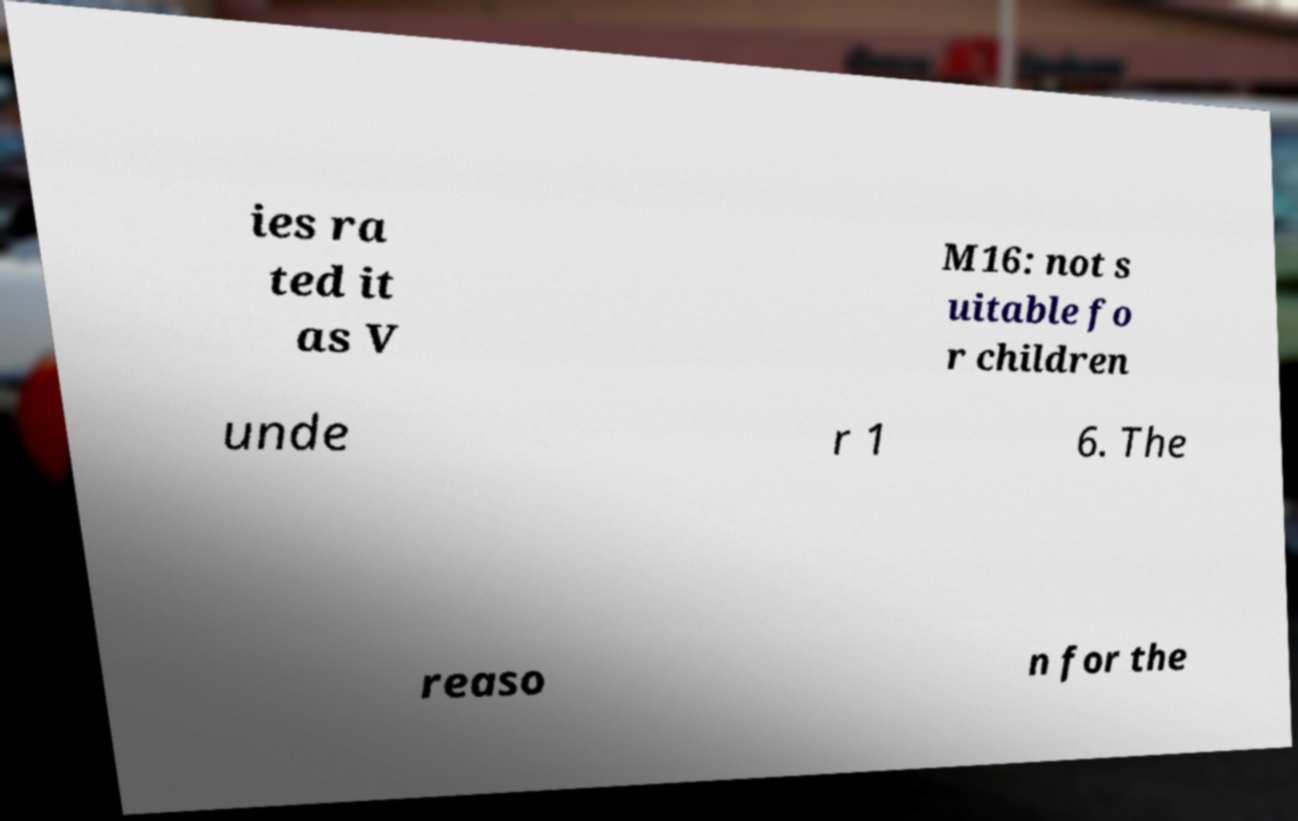I need the written content from this picture converted into text. Can you do that? ies ra ted it as V M16: not s uitable fo r children unde r 1 6. The reaso n for the 